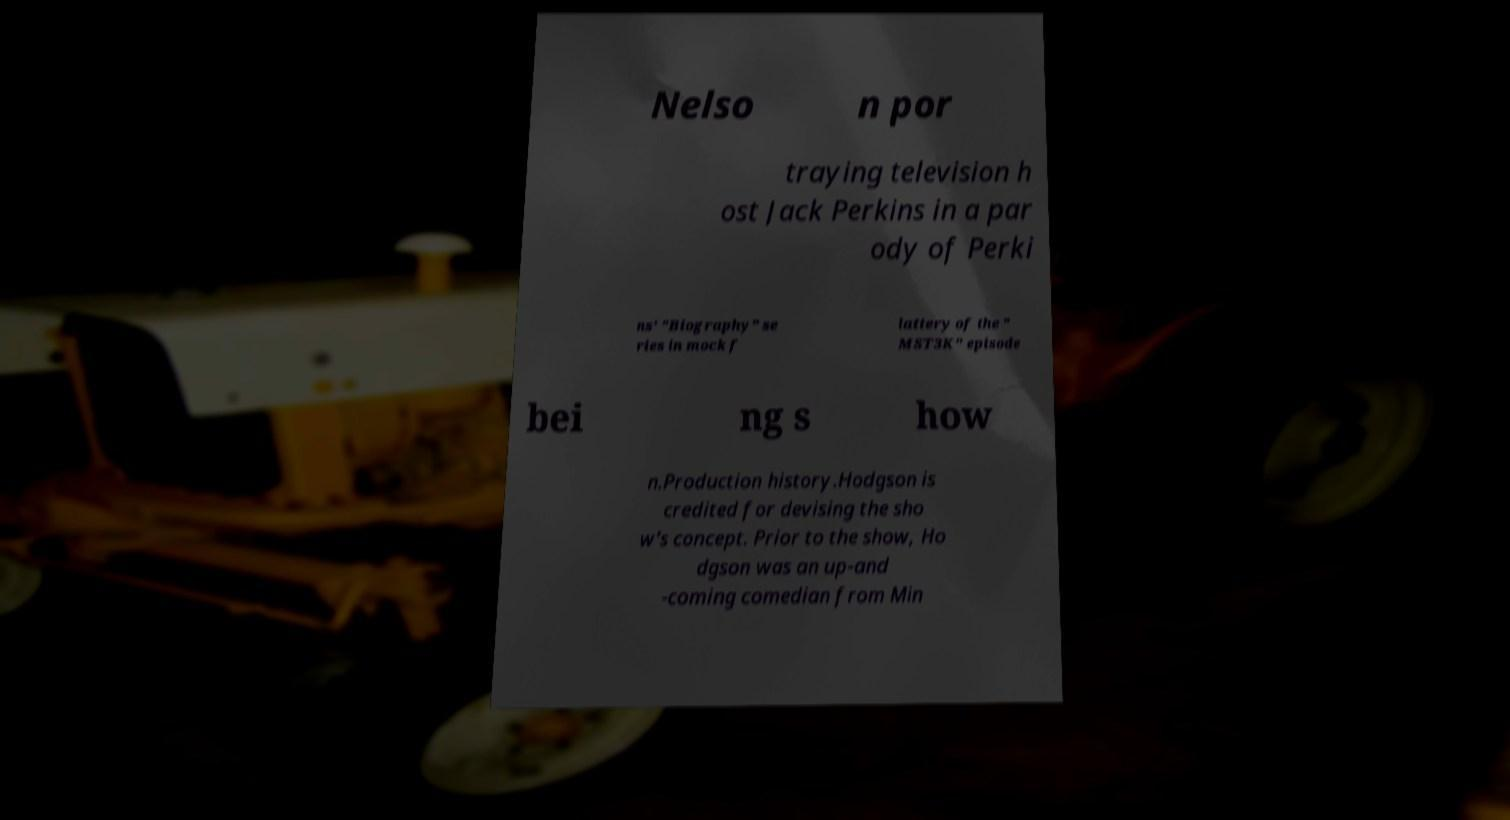Could you extract and type out the text from this image? Nelso n por traying television h ost Jack Perkins in a par ody of Perki ns' "Biography" se ries in mock f lattery of the " MST3K" episode bei ng s how n.Production history.Hodgson is credited for devising the sho w's concept. Prior to the show, Ho dgson was an up-and -coming comedian from Min 